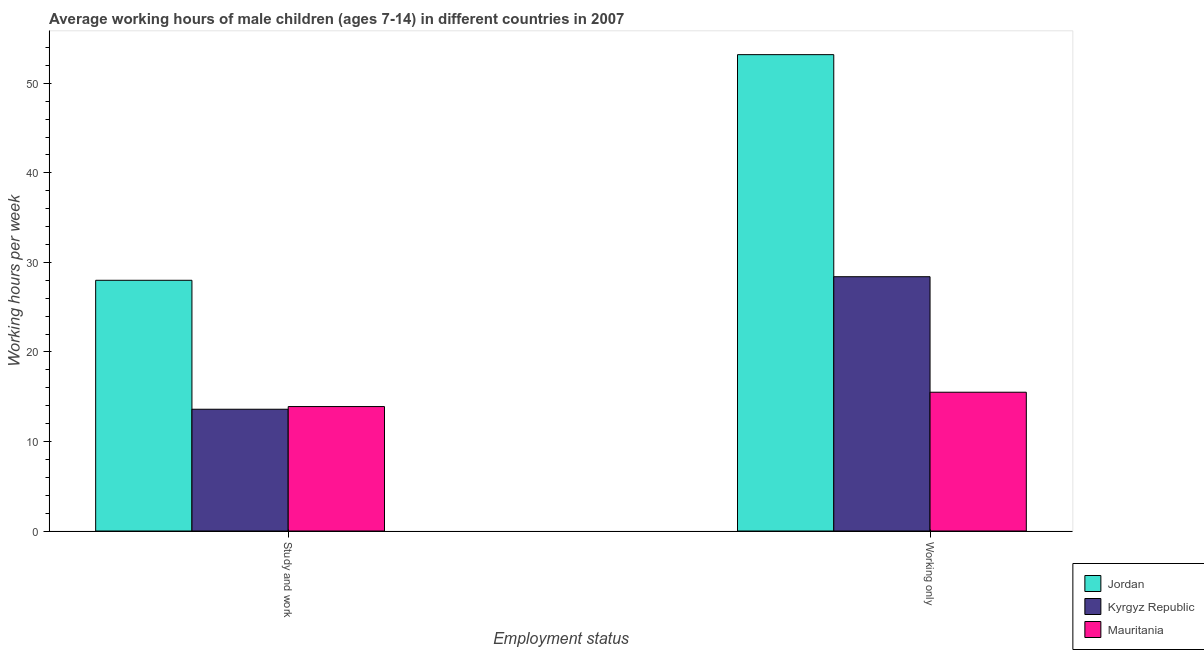How many groups of bars are there?
Give a very brief answer. 2. Are the number of bars per tick equal to the number of legend labels?
Provide a succinct answer. Yes. How many bars are there on the 2nd tick from the right?
Your answer should be compact. 3. What is the label of the 2nd group of bars from the left?
Provide a short and direct response. Working only. What is the average working hour of children involved in study and work in Kyrgyz Republic?
Give a very brief answer. 13.6. Across all countries, what is the maximum average working hour of children involved in only work?
Offer a terse response. 53.2. In which country was the average working hour of children involved in only work maximum?
Give a very brief answer. Jordan. In which country was the average working hour of children involved in only work minimum?
Provide a short and direct response. Mauritania. What is the total average working hour of children involved in only work in the graph?
Make the answer very short. 97.1. What is the difference between the average working hour of children involved in study and work in Kyrgyz Republic and that in Mauritania?
Your answer should be compact. -0.3. What is the difference between the average working hour of children involved in only work in Jordan and the average working hour of children involved in study and work in Kyrgyz Republic?
Your answer should be compact. 39.6. What is the average average working hour of children involved in study and work per country?
Give a very brief answer. 18.5. What is the difference between the average working hour of children involved in only work and average working hour of children involved in study and work in Mauritania?
Your answer should be very brief. 1.6. What is the ratio of the average working hour of children involved in only work in Jordan to that in Kyrgyz Republic?
Provide a short and direct response. 1.87. Is the average working hour of children involved in study and work in Mauritania less than that in Jordan?
Ensure brevity in your answer.  Yes. In how many countries, is the average working hour of children involved in only work greater than the average average working hour of children involved in only work taken over all countries?
Provide a succinct answer. 1. What does the 1st bar from the left in Working only represents?
Offer a terse response. Jordan. What does the 3rd bar from the right in Study and work represents?
Your response must be concise. Jordan. How many bars are there?
Ensure brevity in your answer.  6. Are all the bars in the graph horizontal?
Keep it short and to the point. No. Does the graph contain any zero values?
Your response must be concise. No. What is the title of the graph?
Ensure brevity in your answer.  Average working hours of male children (ages 7-14) in different countries in 2007. Does "Turkey" appear as one of the legend labels in the graph?
Give a very brief answer. No. What is the label or title of the X-axis?
Your response must be concise. Employment status. What is the label or title of the Y-axis?
Offer a very short reply. Working hours per week. What is the Working hours per week in Jordan in Study and work?
Keep it short and to the point. 28. What is the Working hours per week of Kyrgyz Republic in Study and work?
Provide a short and direct response. 13.6. What is the Working hours per week in Mauritania in Study and work?
Give a very brief answer. 13.9. What is the Working hours per week in Jordan in Working only?
Make the answer very short. 53.2. What is the Working hours per week in Kyrgyz Republic in Working only?
Keep it short and to the point. 28.4. What is the Working hours per week in Mauritania in Working only?
Your response must be concise. 15.5. Across all Employment status, what is the maximum Working hours per week in Jordan?
Keep it short and to the point. 53.2. Across all Employment status, what is the maximum Working hours per week in Kyrgyz Republic?
Make the answer very short. 28.4. Across all Employment status, what is the maximum Working hours per week in Mauritania?
Give a very brief answer. 15.5. Across all Employment status, what is the minimum Working hours per week in Kyrgyz Republic?
Give a very brief answer. 13.6. What is the total Working hours per week in Jordan in the graph?
Your answer should be very brief. 81.2. What is the total Working hours per week of Mauritania in the graph?
Ensure brevity in your answer.  29.4. What is the difference between the Working hours per week in Jordan in Study and work and that in Working only?
Provide a short and direct response. -25.2. What is the difference between the Working hours per week in Kyrgyz Republic in Study and work and that in Working only?
Make the answer very short. -14.8. What is the difference between the Working hours per week of Mauritania in Study and work and that in Working only?
Offer a terse response. -1.6. What is the difference between the Working hours per week of Kyrgyz Republic in Study and work and the Working hours per week of Mauritania in Working only?
Ensure brevity in your answer.  -1.9. What is the average Working hours per week of Jordan per Employment status?
Provide a succinct answer. 40.6. What is the difference between the Working hours per week of Jordan and Working hours per week of Mauritania in Study and work?
Make the answer very short. 14.1. What is the difference between the Working hours per week in Jordan and Working hours per week in Kyrgyz Republic in Working only?
Make the answer very short. 24.8. What is the difference between the Working hours per week of Jordan and Working hours per week of Mauritania in Working only?
Your answer should be very brief. 37.7. What is the difference between the Working hours per week of Kyrgyz Republic and Working hours per week of Mauritania in Working only?
Your answer should be compact. 12.9. What is the ratio of the Working hours per week of Jordan in Study and work to that in Working only?
Offer a very short reply. 0.53. What is the ratio of the Working hours per week in Kyrgyz Republic in Study and work to that in Working only?
Your answer should be very brief. 0.48. What is the ratio of the Working hours per week of Mauritania in Study and work to that in Working only?
Make the answer very short. 0.9. What is the difference between the highest and the second highest Working hours per week of Jordan?
Give a very brief answer. 25.2. What is the difference between the highest and the second highest Working hours per week of Kyrgyz Republic?
Offer a terse response. 14.8. What is the difference between the highest and the lowest Working hours per week in Jordan?
Ensure brevity in your answer.  25.2. What is the difference between the highest and the lowest Working hours per week in Kyrgyz Republic?
Your answer should be compact. 14.8. What is the difference between the highest and the lowest Working hours per week of Mauritania?
Provide a short and direct response. 1.6. 